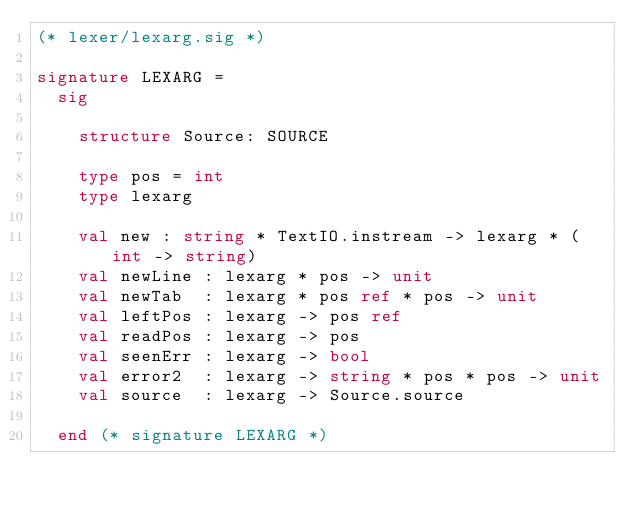<code> <loc_0><loc_0><loc_500><loc_500><_SML_>(* lexer/lexarg.sig *)

signature LEXARG =
  sig

    structure Source: SOURCE

    type pos = int
    type lexarg

    val new	: string * TextIO.instream -> lexarg * (int -> string)
    val newLine	: lexarg * pos -> unit
    val newTab	: lexarg * pos ref * pos -> unit
    val leftPos	: lexarg -> pos ref
    val readPos	: lexarg -> pos
    val seenErr	: lexarg -> bool
    val error2	: lexarg -> string * pos * pos -> unit
    val source	: lexarg -> Source.source

  end (* signature LEXARG *)
</code> 